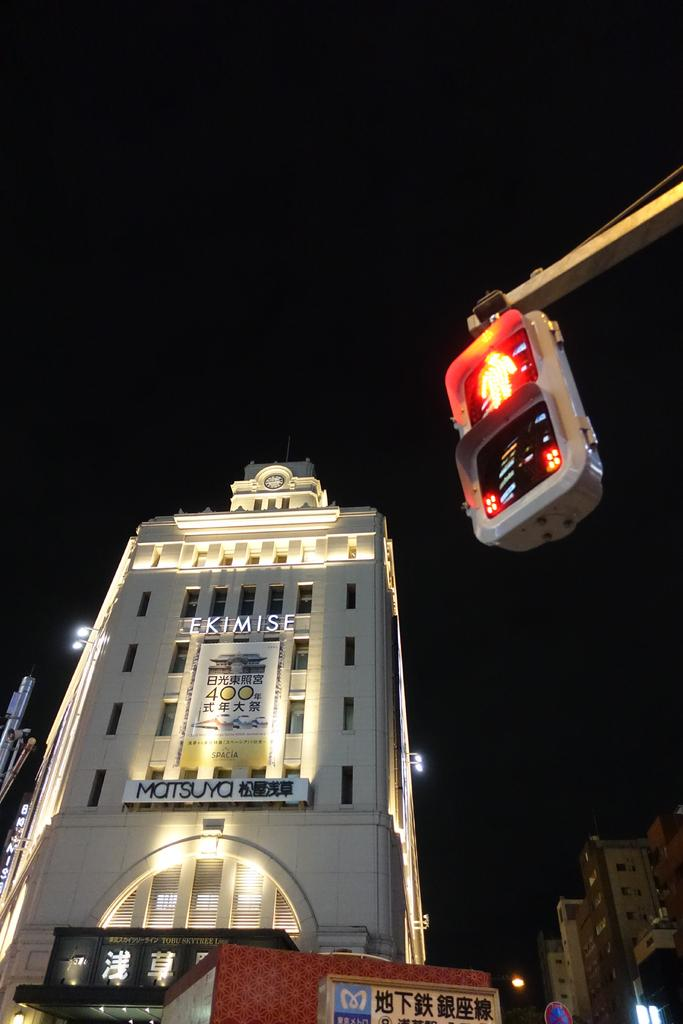<image>
Summarize the visual content of the image. The Ekimise bulding has a large sign that says matsuya on it. 